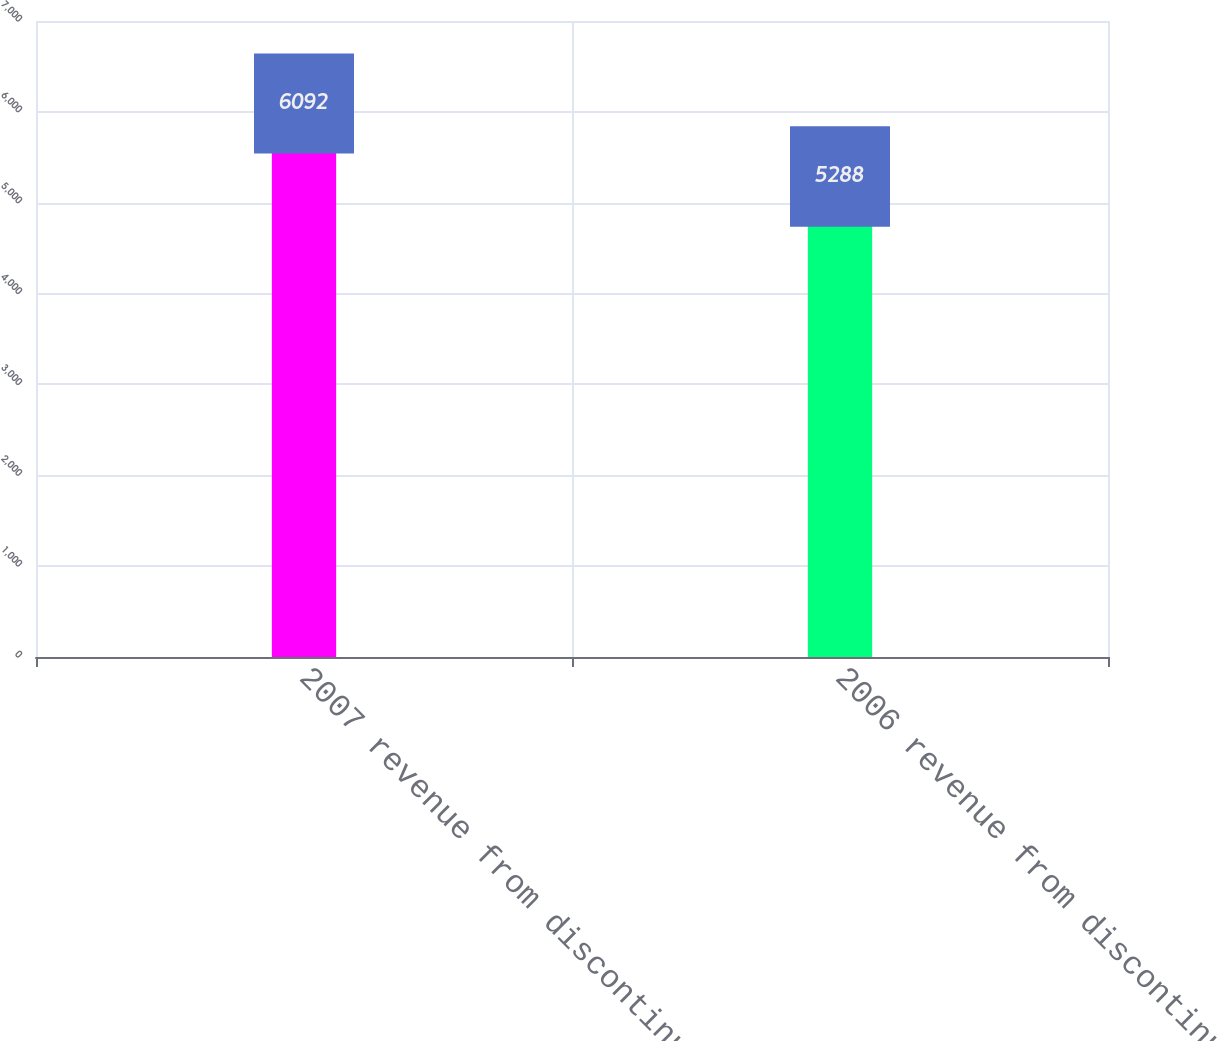Convert chart. <chart><loc_0><loc_0><loc_500><loc_500><bar_chart><fcel>2007 revenue from discontinued<fcel>2006 revenue from discontinued<nl><fcel>6092<fcel>5288<nl></chart> 